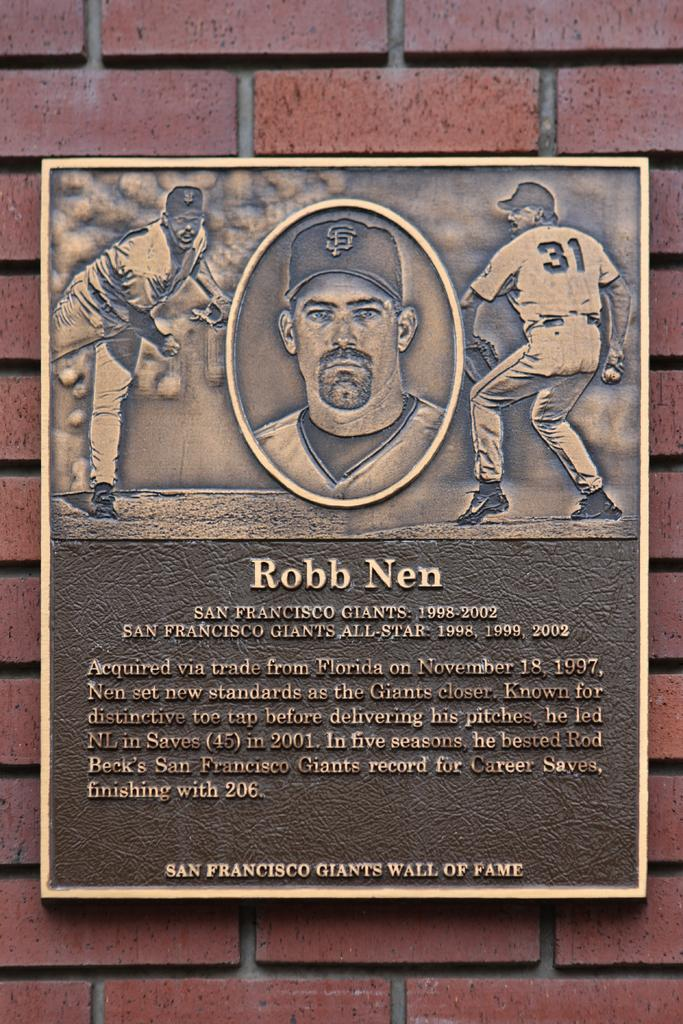What is the main object in the image? There is a frame in the image. What is inside the frame? The frame contains a person's image. Is there any text associated with the person's image? Yes, there is text written below the person's image. What can be seen behind the frame? There is a brick wall behind the frame. How many pages are visible in the image? There are no pages present in the image. What type of blood is visible on the person's image? There is no blood visible on the person's image; it is a photograph. 